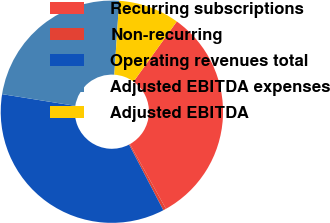Convert chart. <chart><loc_0><loc_0><loc_500><loc_500><pie_chart><fcel>Recurring subscriptions<fcel>Non-recurring<fcel>Operating revenues total<fcel>Adjusted EBITDA expenses<fcel>Adjusted EBITDA<nl><fcel>31.98%<fcel>0.43%<fcel>35.18%<fcel>23.52%<fcel>8.88%<nl></chart> 